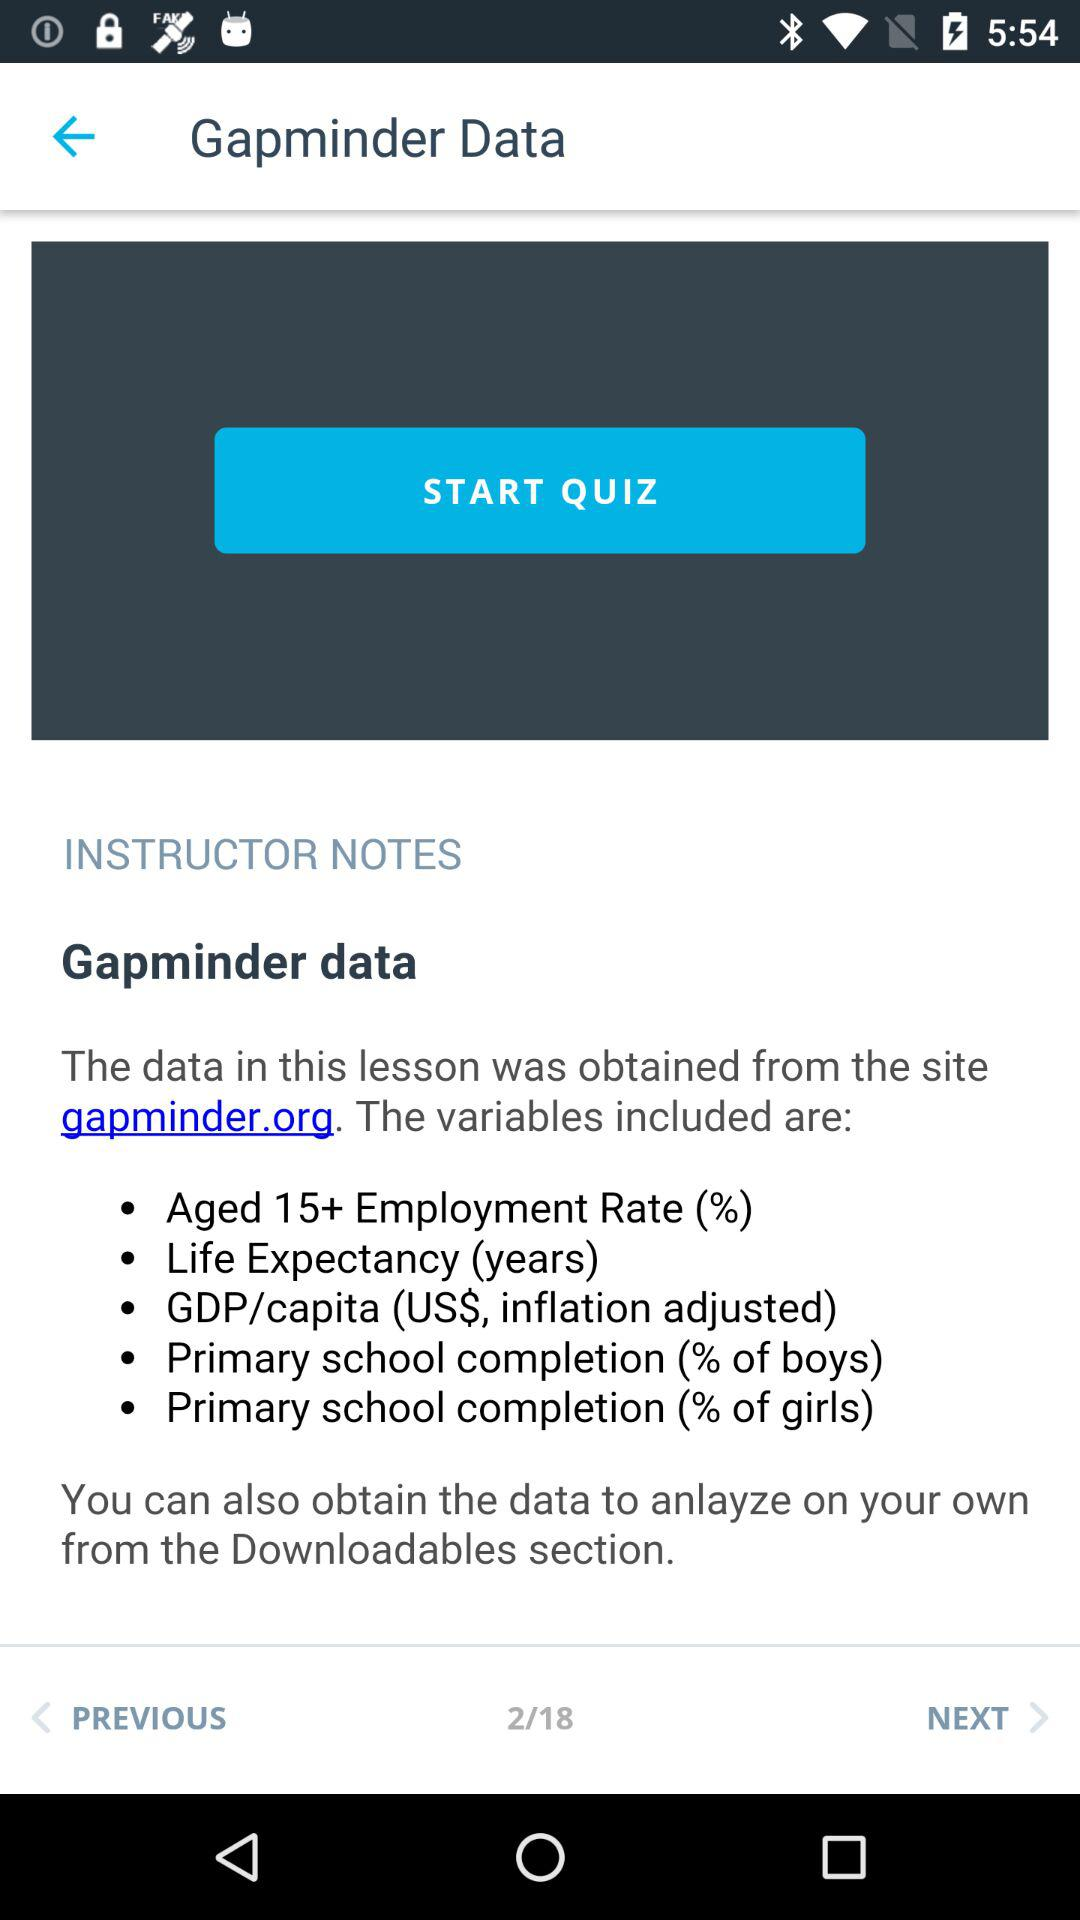What is the site from which the data for the lesson was obtained? The data for the lesson was obtained from the site gapminder.org. 